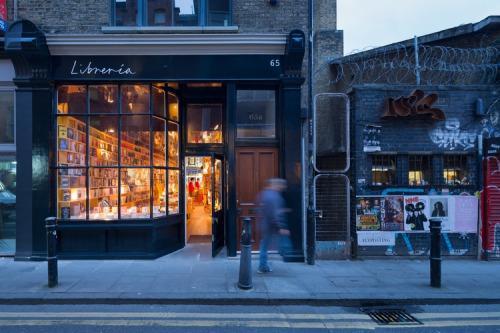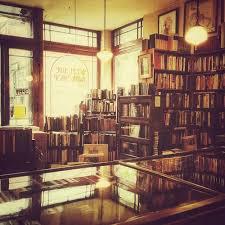The first image is the image on the left, the second image is the image on the right. Examine the images to the left and right. Is the description "To the left, there are some chairs that people can use for sitting." accurate? Answer yes or no. No. The first image is the image on the left, the second image is the image on the right. Considering the images on both sides, is "There is only an image of the inside of a bookstore." valid? Answer yes or no. No. 